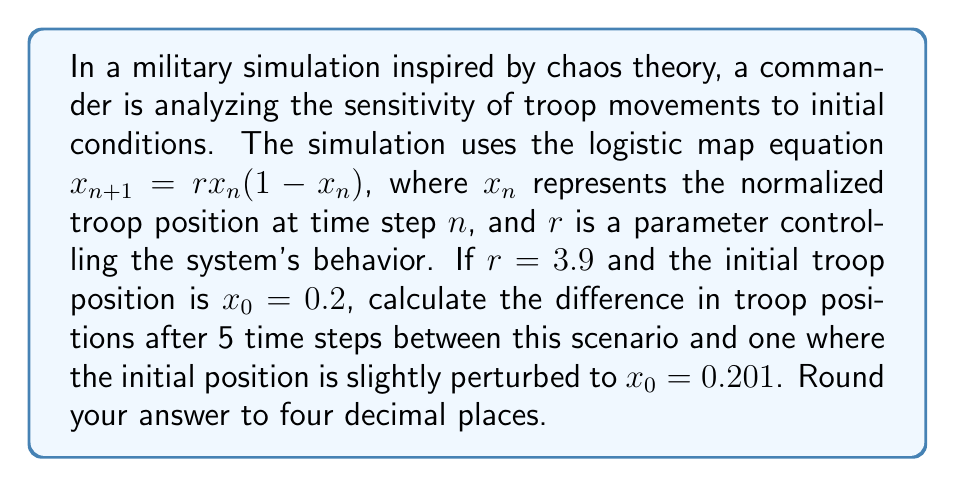Show me your answer to this math problem. Let's approach this step-by-step:

1) We need to calculate two sequences:
   Sequence A: Starting with $x_0 = 0.2$
   Sequence B: Starting with $x_0 = 0.201$

2) We'll use the logistic map equation $x_{n+1} = rx_n(1-x_n)$ with $r = 3.9$ for both sequences.

3) For Sequence A:
   $x_1 = 3.9 * 0.2 * (1-0.2) = 0.624$
   $x_2 = 3.9 * 0.624 * (1-0.624) = 0.9165984$
   $x_3 = 3.9 * 0.9165984 * (1-0.9165984) = 0.3008707$
   $x_4 = 3.9 * 0.3008707 * (1-0.3008707) = 0.8206422$
   $x_5 = 3.9 * 0.8206422 * (1-0.8206422) = 0.5752390$

4) For Sequence B:
   $x_1 = 3.9 * 0.201 * (1-0.201) = 0.6260361$
   $x_2 = 3.9 * 0.6260361 * (1-0.6260361) = 0.9157950$
   $x_3 = 3.9 * 0.9157950 * (1-0.9157950) = 0.3018592$
   $x_4 = 3.9 * 0.3018592 * (1-0.3018592) = 0.8213190$
   $x_5 = 3.9 * 0.8213190 * (1-0.8213190) = 0.5736302$

5) The difference after 5 time steps is:
   $|x_5(A) - x_5(B)| = |0.5752390 - 0.5736302| = 0.0016088$

6) Rounding to four decimal places: 0.0016
Answer: 0.0016 